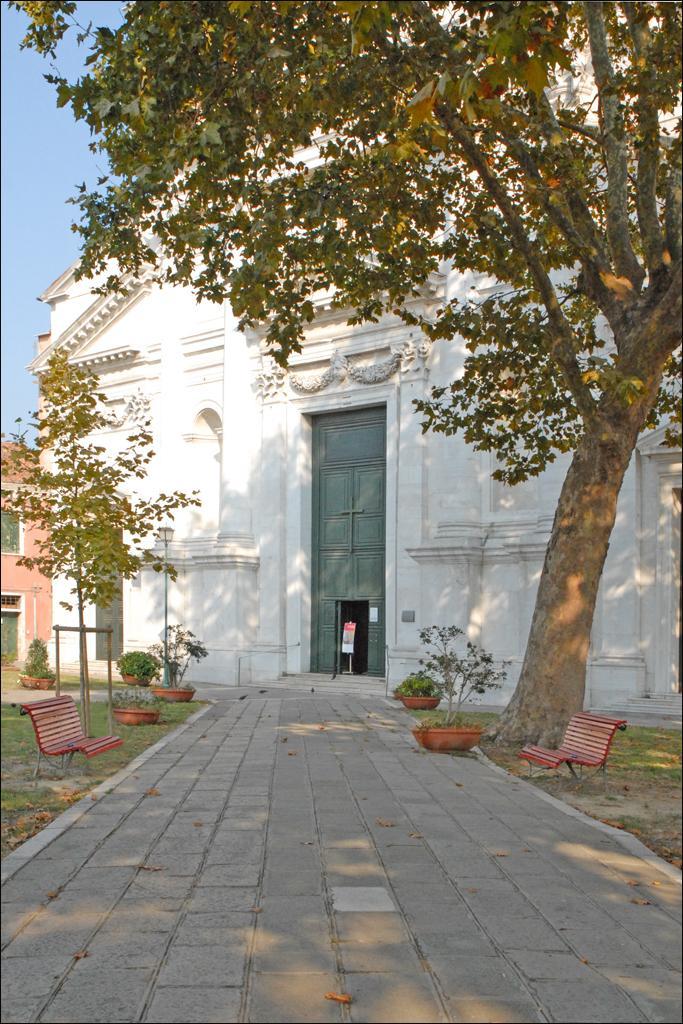Describe this image in one or two sentences. In this image I can see a building in white color, at left and right I can see benches in orange color and trees in green color. At top sky is in blue color. 